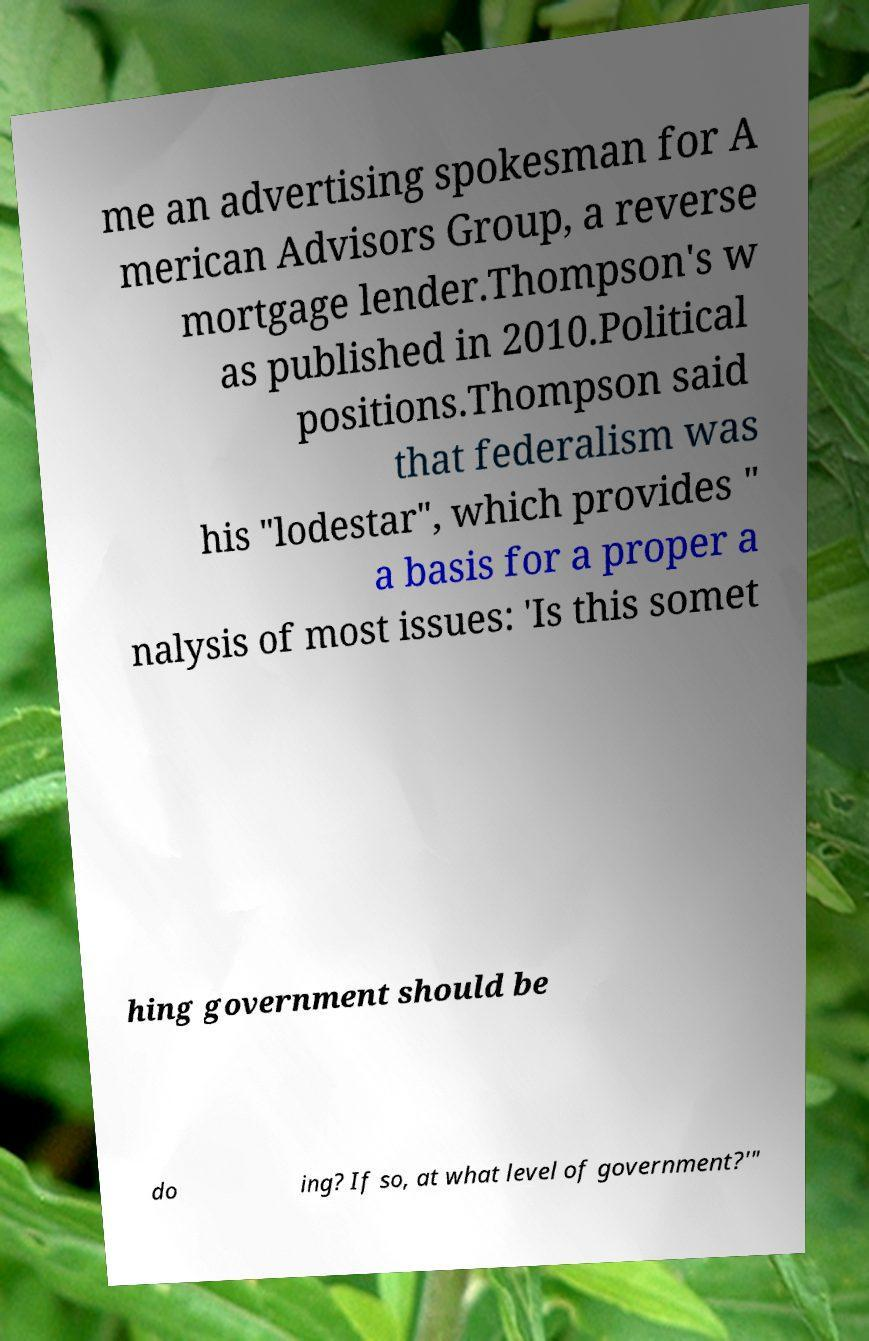For documentation purposes, I need the text within this image transcribed. Could you provide that? me an advertising spokesman for A merican Advisors Group, a reverse mortgage lender.Thompson's w as published in 2010.Political positions.Thompson said that federalism was his "lodestar", which provides " a basis for a proper a nalysis of most issues: 'Is this somet hing government should be do ing? If so, at what level of government?'" 